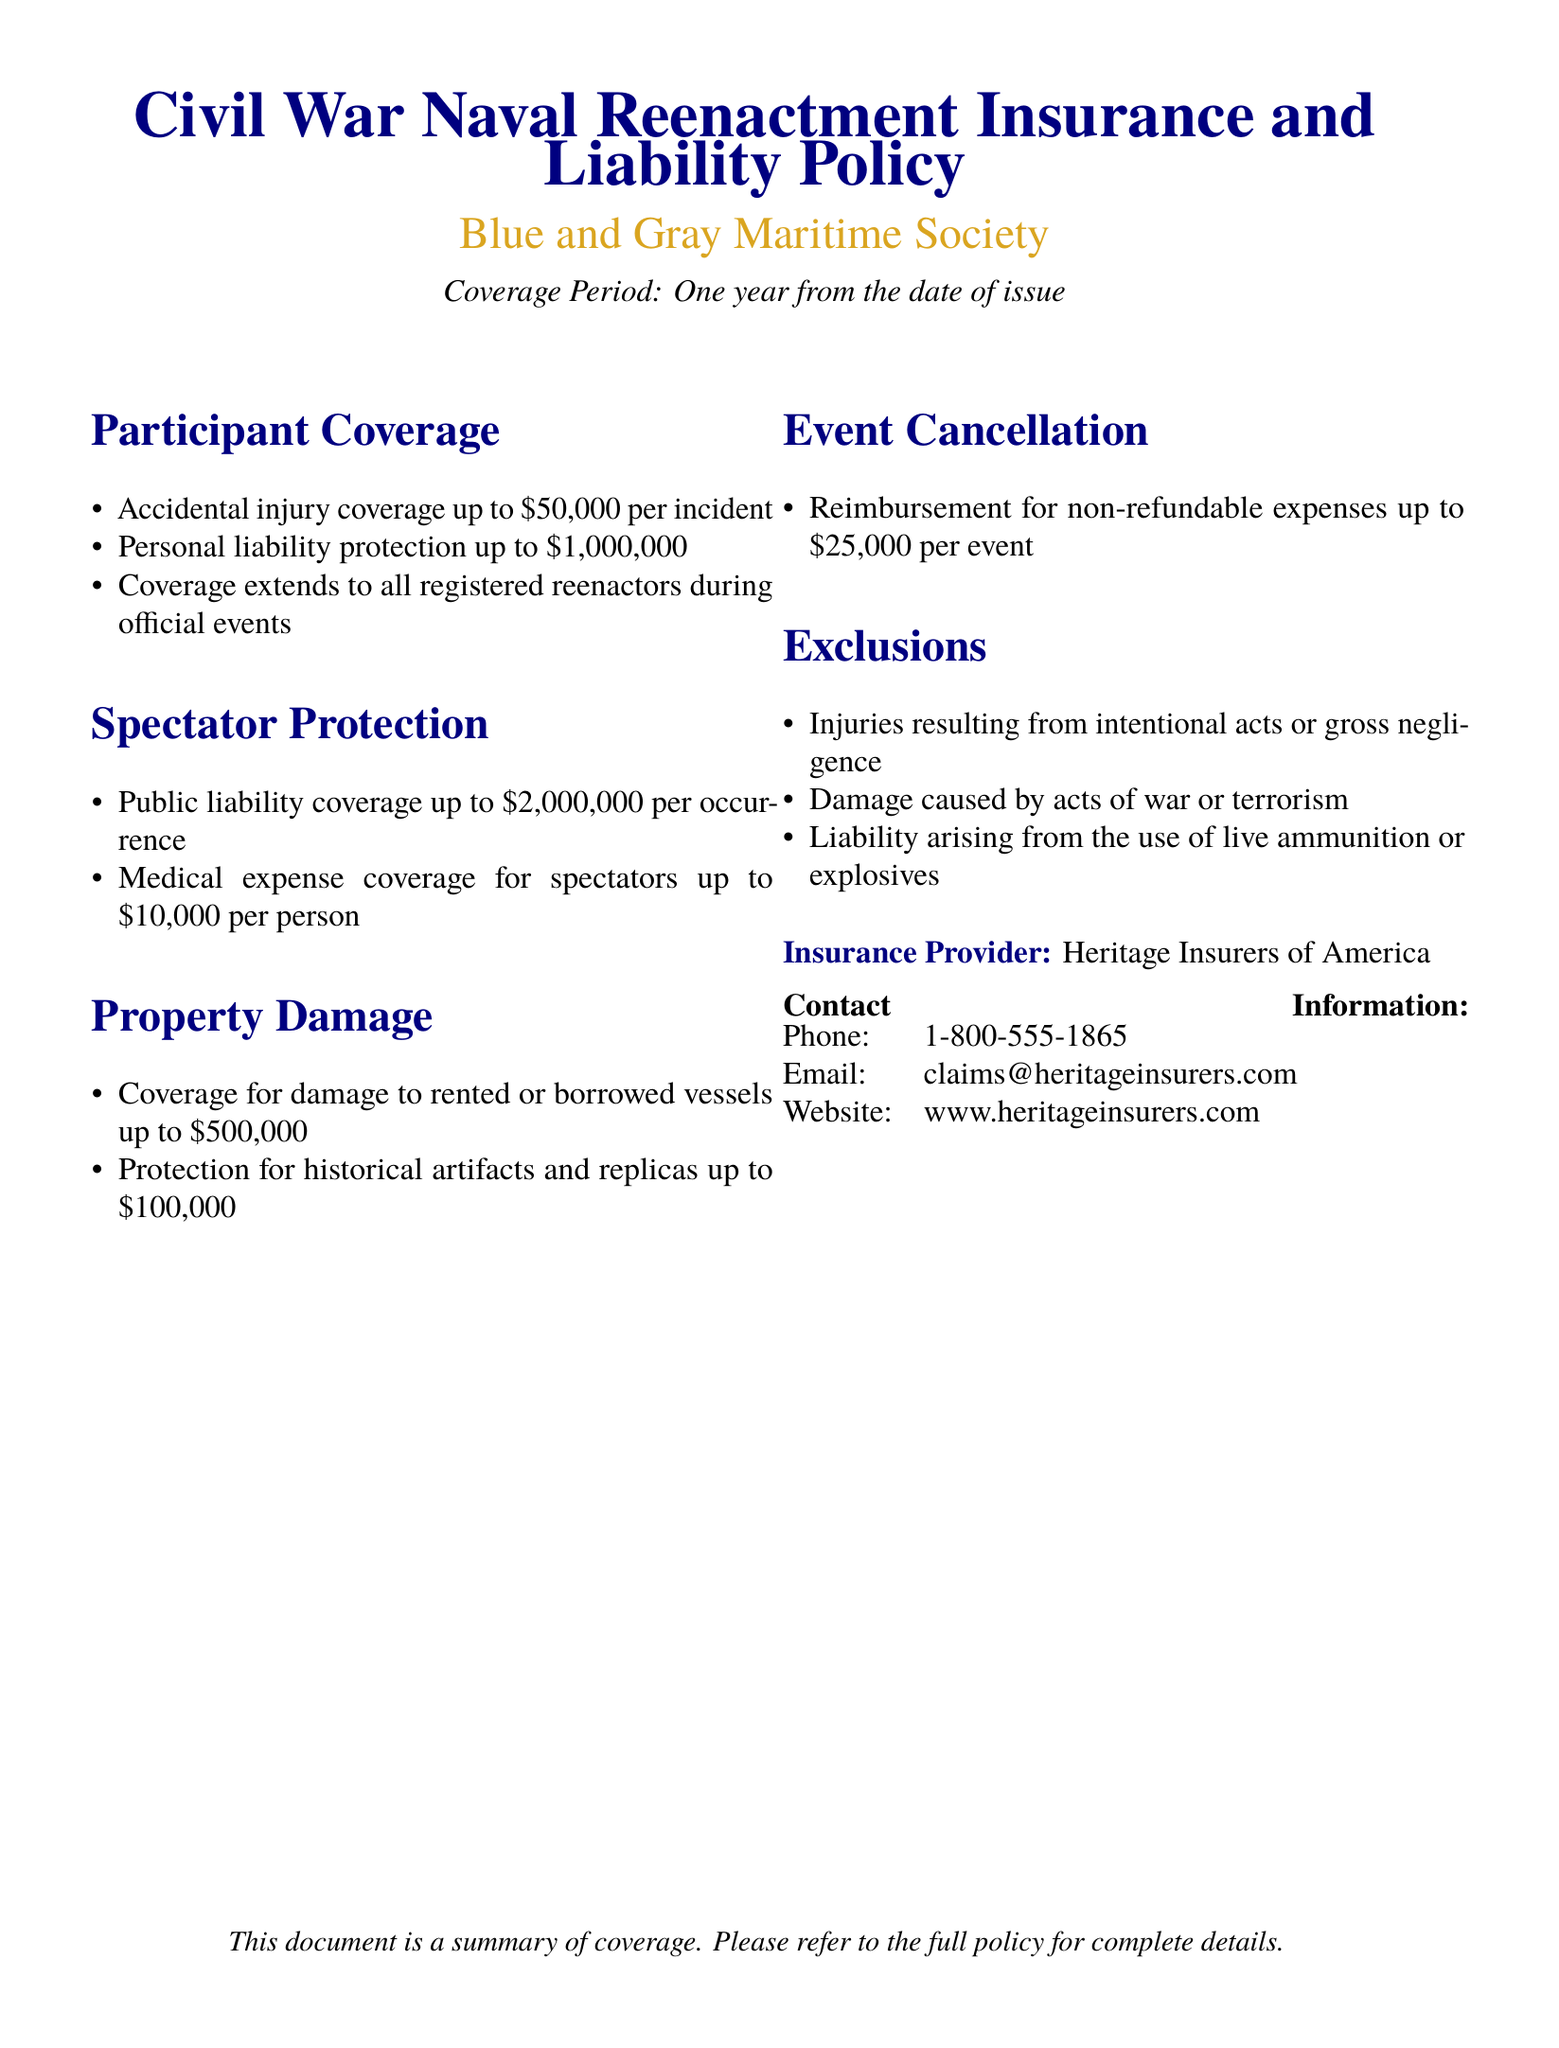what is the accidental injury coverage limit per incident? The document states that accidental injury coverage is up to $50,000 per incident.
Answer: $50,000 what is the public liability coverage for spectators? The document specifies that public liability coverage for spectators is up to $2,000,000 per occurrence.
Answer: $2,000,000 what is the reimbursement limit for event cancellation expenses? The document mentions reimbursement for non-refundable expenses up to $25,000 per event.
Answer: $25,000 how much coverage is there for damage to rented vessels? According to the document, coverage for damage to rented vessels is up to $500,000.
Answer: $500,000 what is excluded from participant coverage? The document outlines that injuries resulting from intentional acts or gross negligence are excluded.
Answer: intentional acts or gross negligence what is the coverage limit for historical artifacts and replicas? The document states that protection for historical artifacts and replicas is up to $100,000.
Answer: $100,000 who is the insurance provider? The document specifies that the insurance provider is Heritage Insurers of America.
Answer: Heritage Insurers of America what is the coverage period for the policy? The document indicates that the coverage period is one year from the date of issue.
Answer: one year what should be referred to for complete details of the policy? The document notes that the full policy should be referred to for complete details.
Answer: full policy 